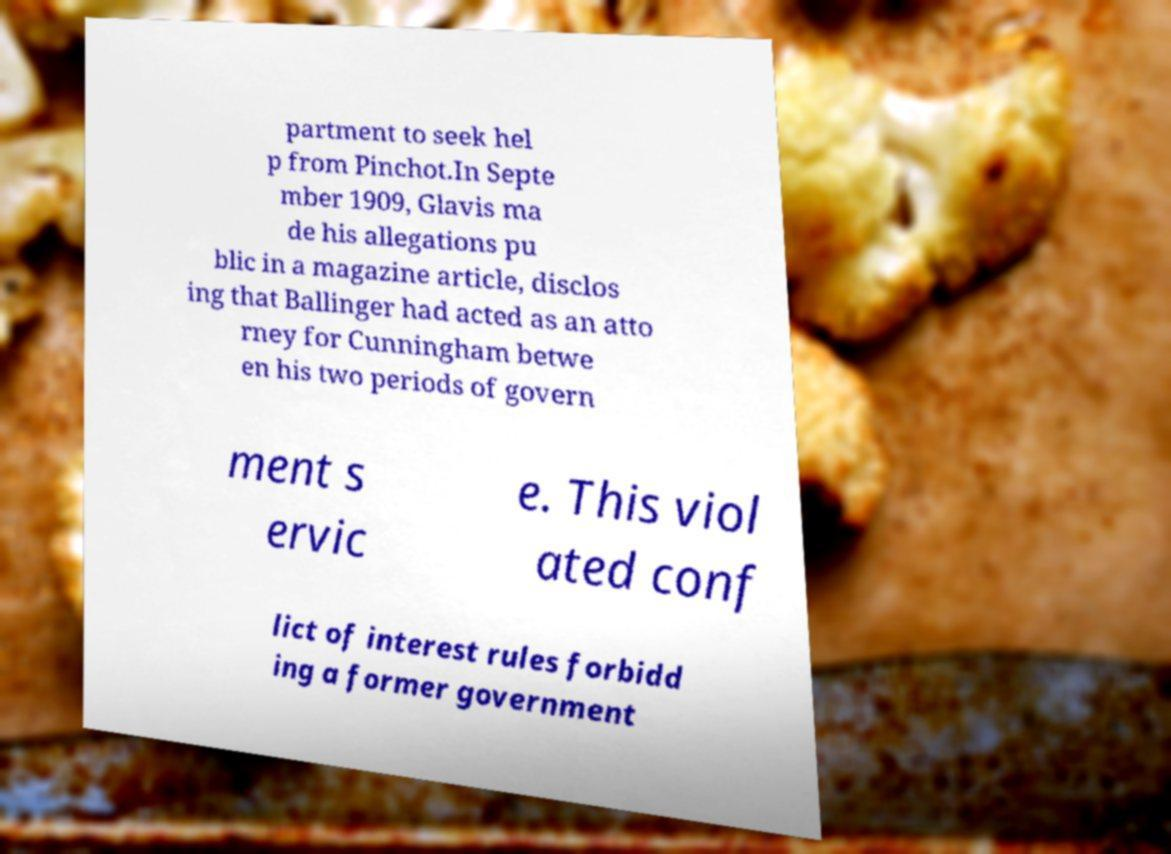Can you accurately transcribe the text from the provided image for me? partment to seek hel p from Pinchot.In Septe mber 1909, Glavis ma de his allegations pu blic in a magazine article, disclos ing that Ballinger had acted as an atto rney for Cunningham betwe en his two periods of govern ment s ervic e. This viol ated conf lict of interest rules forbidd ing a former government 